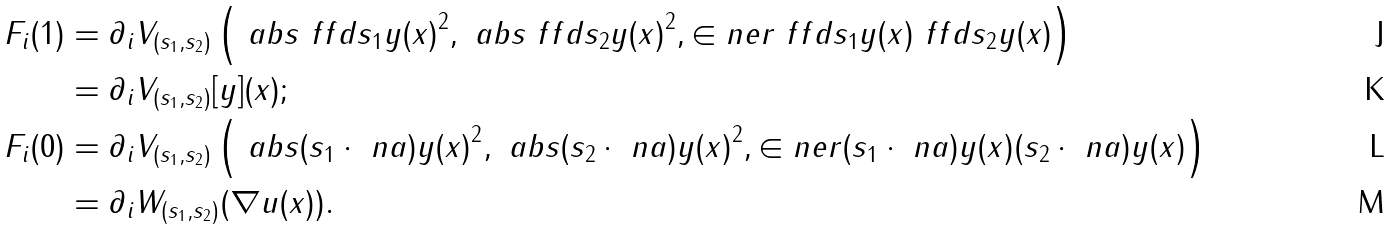Convert formula to latex. <formula><loc_0><loc_0><loc_500><loc_500>F _ { i } ( 1 ) & = \partial _ { i } V _ { ( s _ { 1 } , s _ { 2 } ) } \left ( \ a b s { \ f f d { s _ { 1 } } y ( x ) } ^ { 2 } , \ a b s { \ f f d { s _ { 2 } } y ( x ) } ^ { 2 } , \in n e r { \ f f d { s _ { 1 } } y ( x ) } { \ f f d { s _ { 2 } } y ( x ) } \right ) \\ & = \partial _ { i } V _ { ( s _ { 1 } , s _ { 2 } ) } [ y ] ( x ) ; \\ F _ { i } ( 0 ) & = \partial _ { i } V _ { ( s _ { 1 } , s _ { 2 } ) } \left ( \ a b s { ( s _ { 1 } \cdot \ n a ) y ( x ) } ^ { 2 } , \ a b s { ( s _ { 2 } \cdot \ n a ) y ( x ) } ^ { 2 } , \in n e r { ( s _ { 1 } \cdot \ n a ) y ( x ) } { ( s _ { 2 } \cdot \ n a ) y ( x ) } \right ) \\ & = \partial _ { i } W _ { ( s _ { 1 } , s _ { 2 } ) } ( \nabla u ( x ) ) .</formula> 